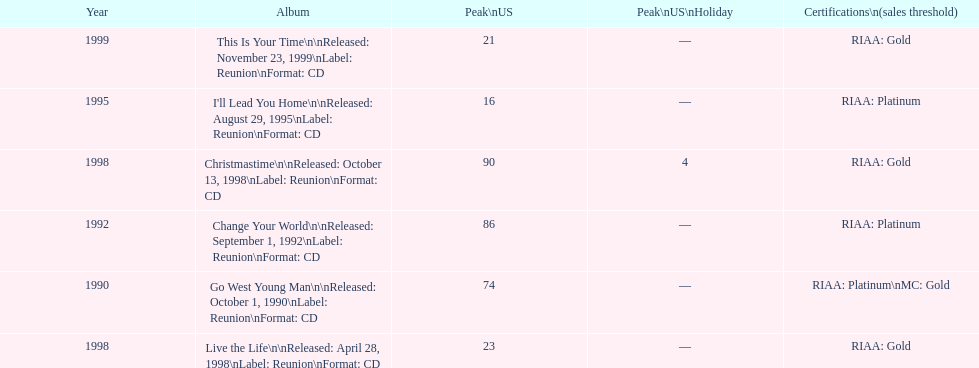What was the first michael w smith album? Go West Young Man. 